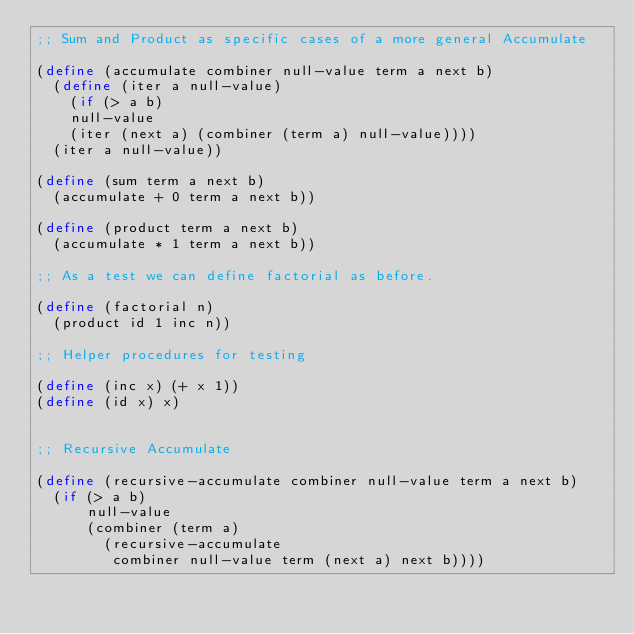Convert code to text. <code><loc_0><loc_0><loc_500><loc_500><_Scheme_>;; Sum and Product as specific cases of a more general Accumulate

(define (accumulate combiner null-value term a next b)
  (define (iter a null-value)
    (if (> a b)
	null-value
	(iter (next a) (combiner (term a) null-value))))
  (iter a null-value))

(define (sum term a next b)
  (accumulate + 0 term a next b))

(define (product term a next b)
  (accumulate * 1 term a next b))

;; As a test we can define factorial as before.

(define (factorial n)
  (product id 1 inc n))

;; Helper procedures for testing

(define (inc x) (+ x 1))
(define (id x) x)


;; Recursive Accumulate

(define (recursive-accumulate combiner null-value term a next b)
  (if (> a b)
      null-value
      (combiner (term a)
		(recursive-accumulate
		 combiner null-value term (next a) next b))))

</code> 